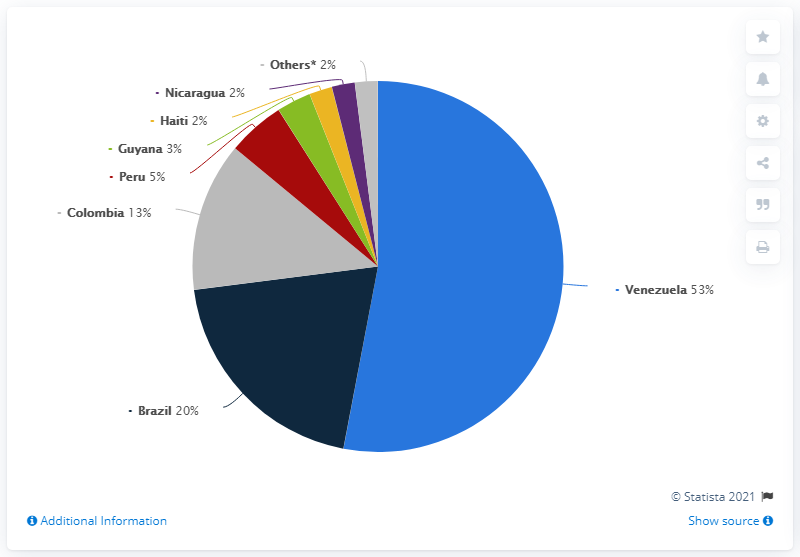Specify some key components in this picture. Venezuela is the country with the highest number of reported malaria cases. Brazil has a significantly higher population compared to Haiti, with a ratio of approximately 10 to 1. Brazil ranked second in terms of malaria cases, accounting for 20% of the total cases globally. Venezuela was the Latin American and Caribbean country most affected by malaria in 2018, according to reports. 